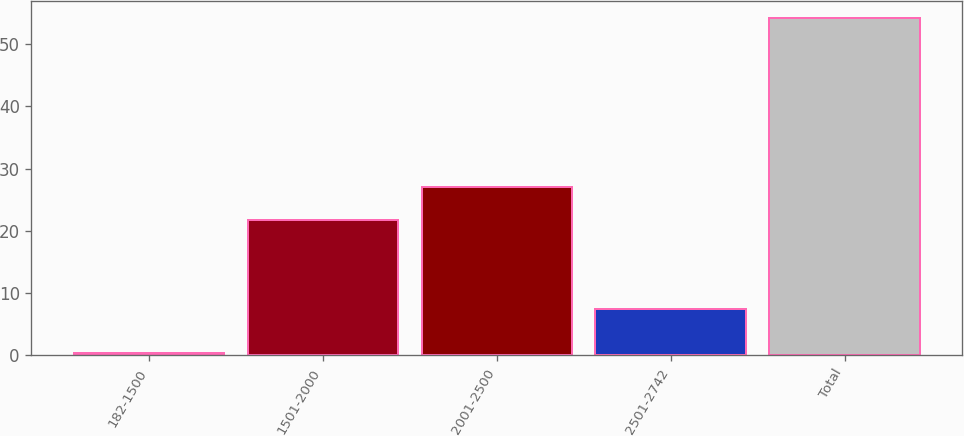Convert chart to OTSL. <chart><loc_0><loc_0><loc_500><loc_500><bar_chart><fcel>182-1500<fcel>1501-2000<fcel>2001-2500<fcel>2501-2742<fcel>Total<nl><fcel>0.4<fcel>21.7<fcel>27.08<fcel>7.4<fcel>54.2<nl></chart> 